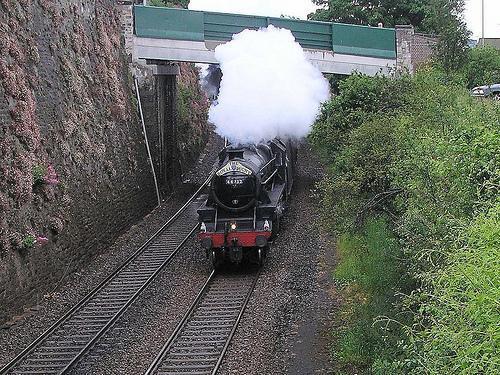How many trains are shown?
Give a very brief answer. 1. 